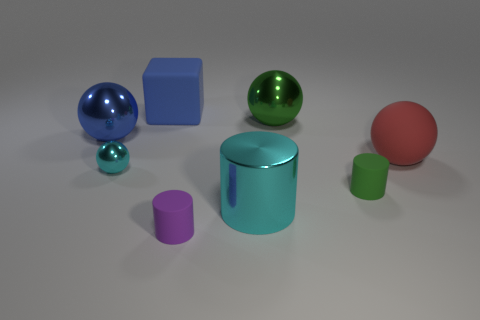Subtract all red cylinders. Subtract all yellow cubes. How many cylinders are left? 3 Add 2 red matte spheres. How many objects exist? 10 Subtract all blocks. How many objects are left? 7 Subtract 1 green cylinders. How many objects are left? 7 Subtract all tiny cyan matte spheres. Subtract all green rubber objects. How many objects are left? 7 Add 5 blue things. How many blue things are left? 7 Add 1 green rubber cylinders. How many green rubber cylinders exist? 2 